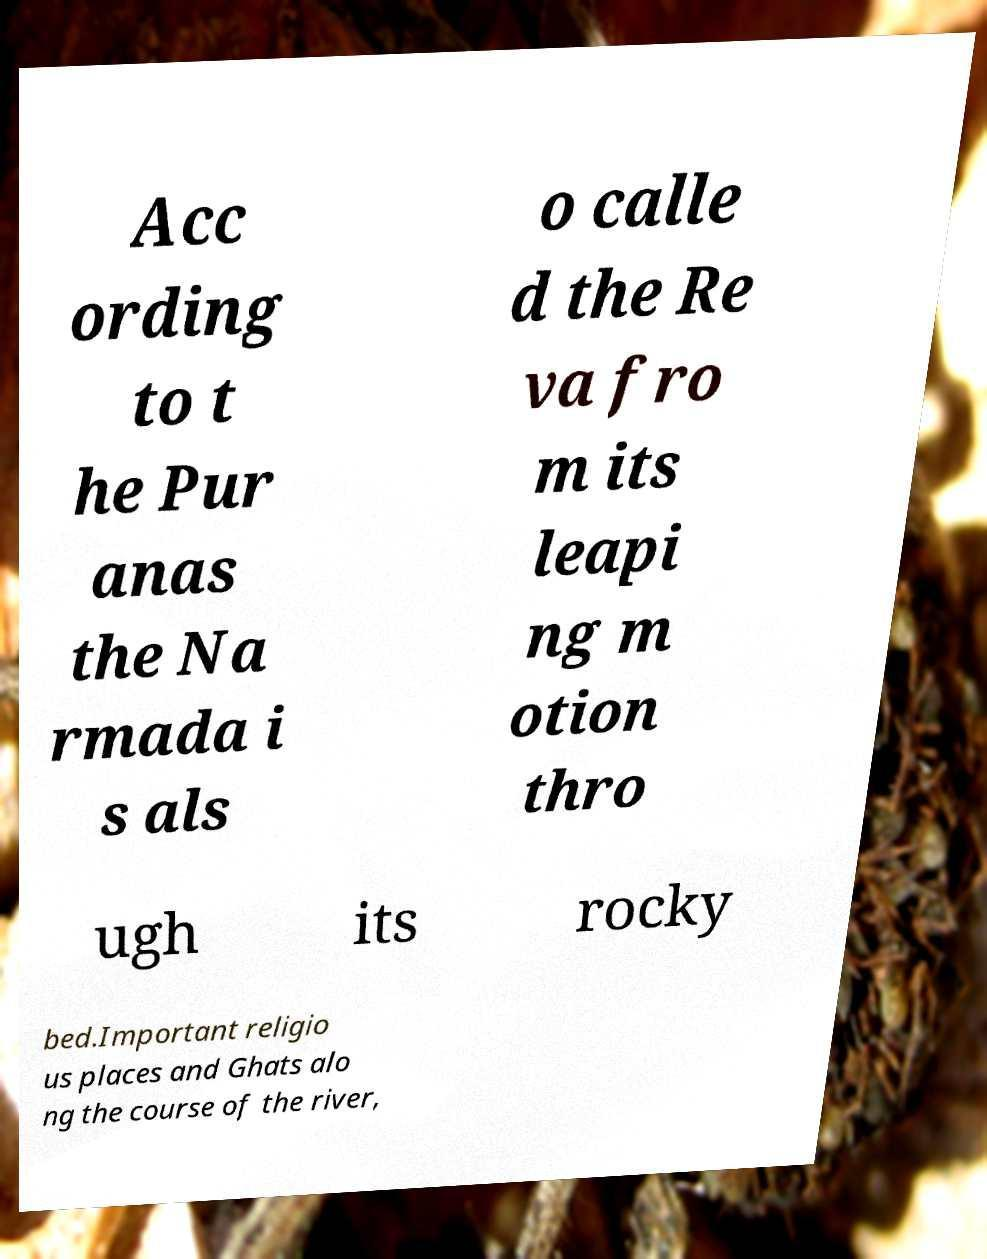Can you accurately transcribe the text from the provided image for me? Acc ording to t he Pur anas the Na rmada i s als o calle d the Re va fro m its leapi ng m otion thro ugh its rocky bed.Important religio us places and Ghats alo ng the course of the river, 